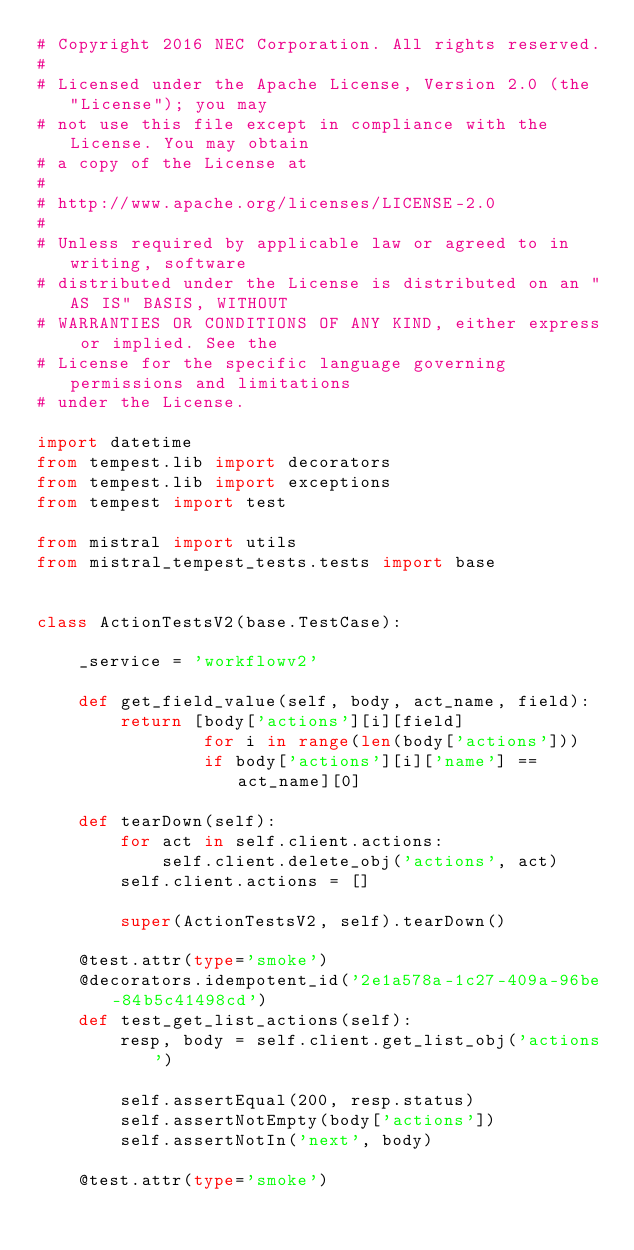Convert code to text. <code><loc_0><loc_0><loc_500><loc_500><_Python_># Copyright 2016 NEC Corporation. All rights reserved.
#
# Licensed under the Apache License, Version 2.0 (the "License"); you may
# not use this file except in compliance with the License. You may obtain
# a copy of the License at
#
# http://www.apache.org/licenses/LICENSE-2.0
#
# Unless required by applicable law or agreed to in writing, software
# distributed under the License is distributed on an "AS IS" BASIS, WITHOUT
# WARRANTIES OR CONDITIONS OF ANY KIND, either express or implied. See the
# License for the specific language governing permissions and limitations
# under the License.

import datetime
from tempest.lib import decorators
from tempest.lib import exceptions
from tempest import test

from mistral import utils
from mistral_tempest_tests.tests import base


class ActionTestsV2(base.TestCase):

    _service = 'workflowv2'

    def get_field_value(self, body, act_name, field):
        return [body['actions'][i][field]
                for i in range(len(body['actions']))
                if body['actions'][i]['name'] == act_name][0]

    def tearDown(self):
        for act in self.client.actions:
            self.client.delete_obj('actions', act)
        self.client.actions = []

        super(ActionTestsV2, self).tearDown()

    @test.attr(type='smoke')
    @decorators.idempotent_id('2e1a578a-1c27-409a-96be-84b5c41498cd')
    def test_get_list_actions(self):
        resp, body = self.client.get_list_obj('actions')

        self.assertEqual(200, resp.status)
        self.assertNotEmpty(body['actions'])
        self.assertNotIn('next', body)

    @test.attr(type='smoke')</code> 